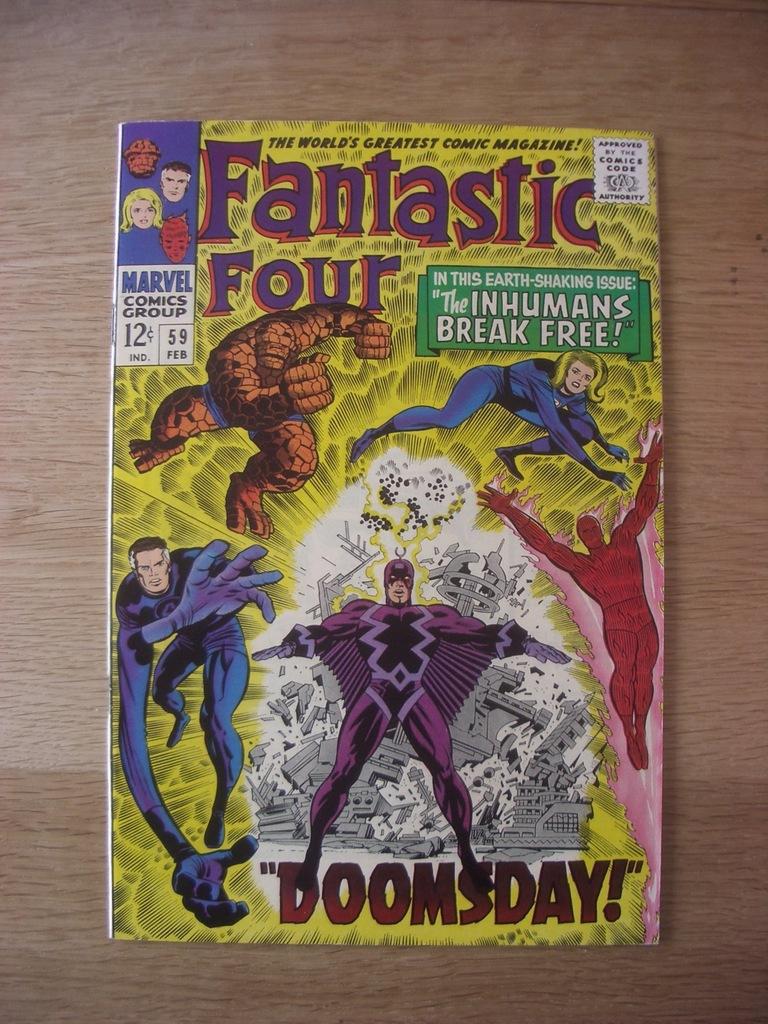What superhero group is the comic about?
Your answer should be very brief. Fantastic four. Whats the book about?
Give a very brief answer. Fantastic four. 